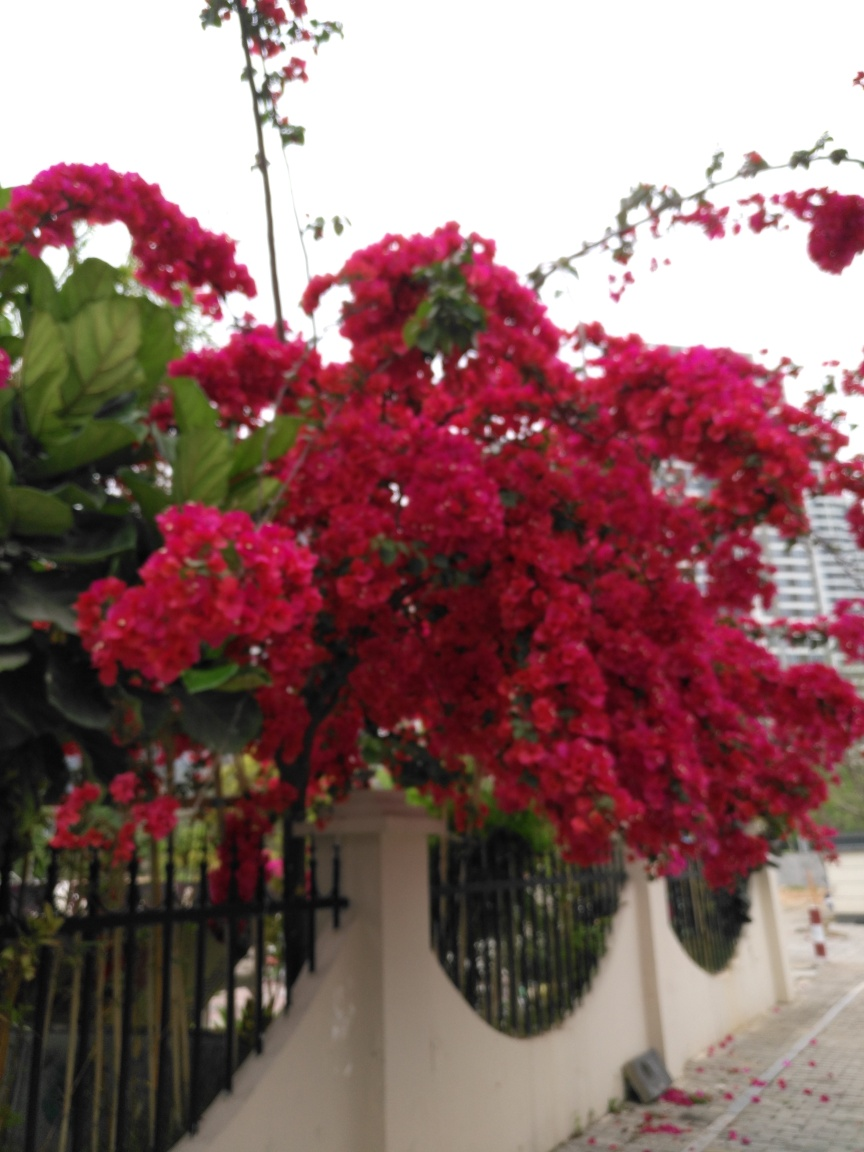Are the buildings in the background blurry? Yes, the buildings in the background are indeed blurry. The photograph features a prominent foreground with vibrant red flowers, which seems to be the focus of the image. The blurriness of the buildings behind provides a contrast that emphasizes the rich detail and colour of the flowers. 